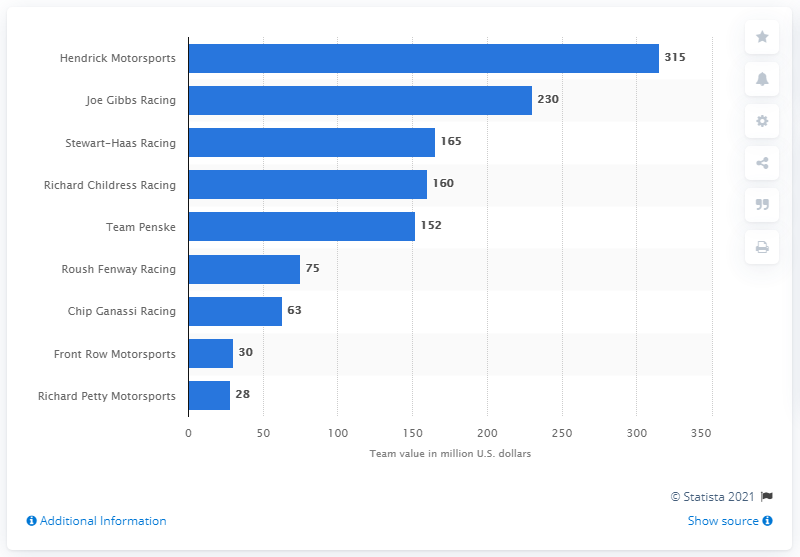List a handful of essential elements in this visual. In 2019, Hendrick Motorsports was the most valuable NASCAR racing team. 